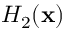Convert formula to latex. <formula><loc_0><loc_0><loc_500><loc_500>H _ { 2 } ( x )</formula> 